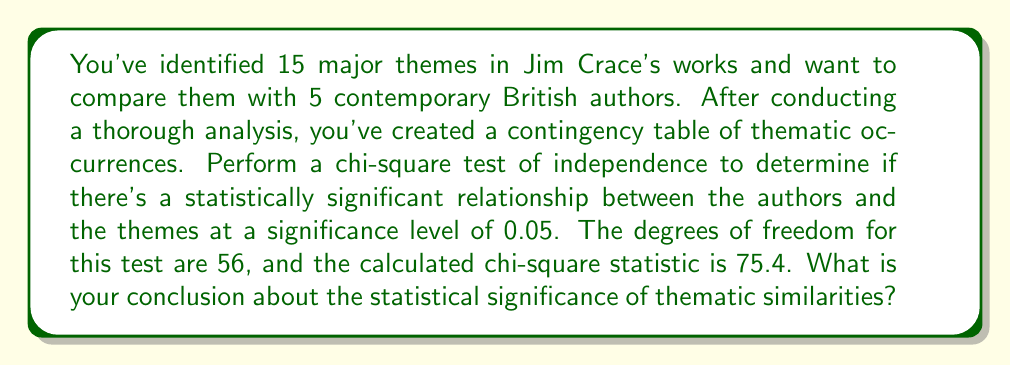Help me with this question. To determine the statistical significance of thematic similarities between Crace's works and other authors, we'll follow these steps:

1. Identify the null and alternative hypotheses:
   $H_0$: There is no significant relationship between authors and themes
   $H_a$: There is a significant relationship between authors and themes

2. Determine the critical value:
   For $\alpha = 0.05$ and $df = 56$, we need to find the critical value from the chi-square distribution table. The critical value is approximately 74.47.

3. Compare the calculated chi-square statistic to the critical value:
   Calculated $\chi^2 = 75.4$
   Critical value $= 74.47$

   Since $75.4 > 74.47$, we reject the null hypothesis.

4. Calculate the p-value:
   The p-value for $\chi^2 = 75.4$ with $df = 56$ is approximately 0.0442.
   Since $p < \alpha$ (0.0442 < 0.05), this confirms our decision to reject the null hypothesis.

5. Interpret the results:
   Rejecting the null hypothesis means there is sufficient evidence to conclude that there is a statistically significant relationship between the authors and the themes at the 0.05 significance level.
Answer: Reject $H_0$; statistically significant relationship exists (p = 0.0442). 